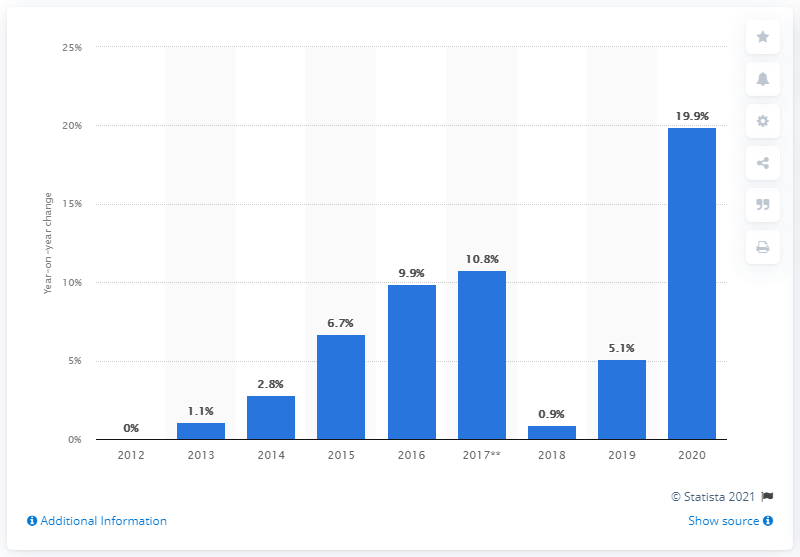List a handful of essential elements in this visual. In December 2020, retail sales of building materials and garden equipment and supplies increased by 19.9% compared to the previous year. 